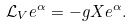<formula> <loc_0><loc_0><loc_500><loc_500>\mathcal { L } _ { V } e ^ { \alpha } = - { g } X e ^ { \alpha } .</formula> 